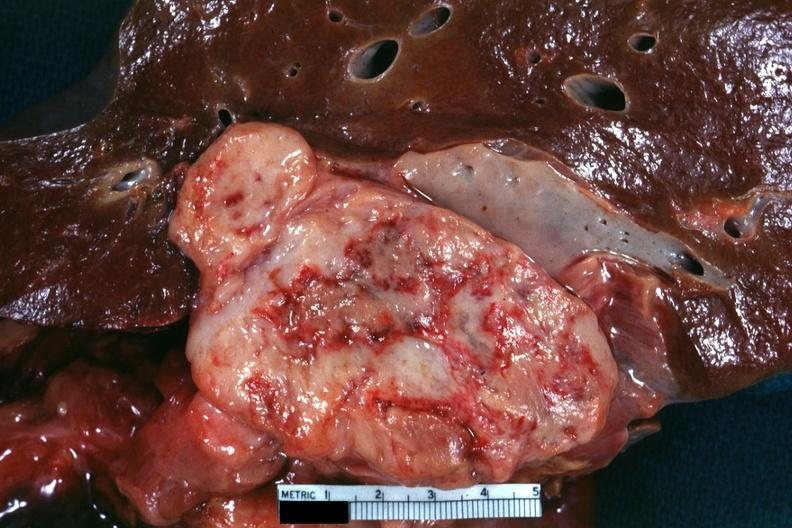where is this area in the body?
Answer the question using a single word or phrase. Abdomen 